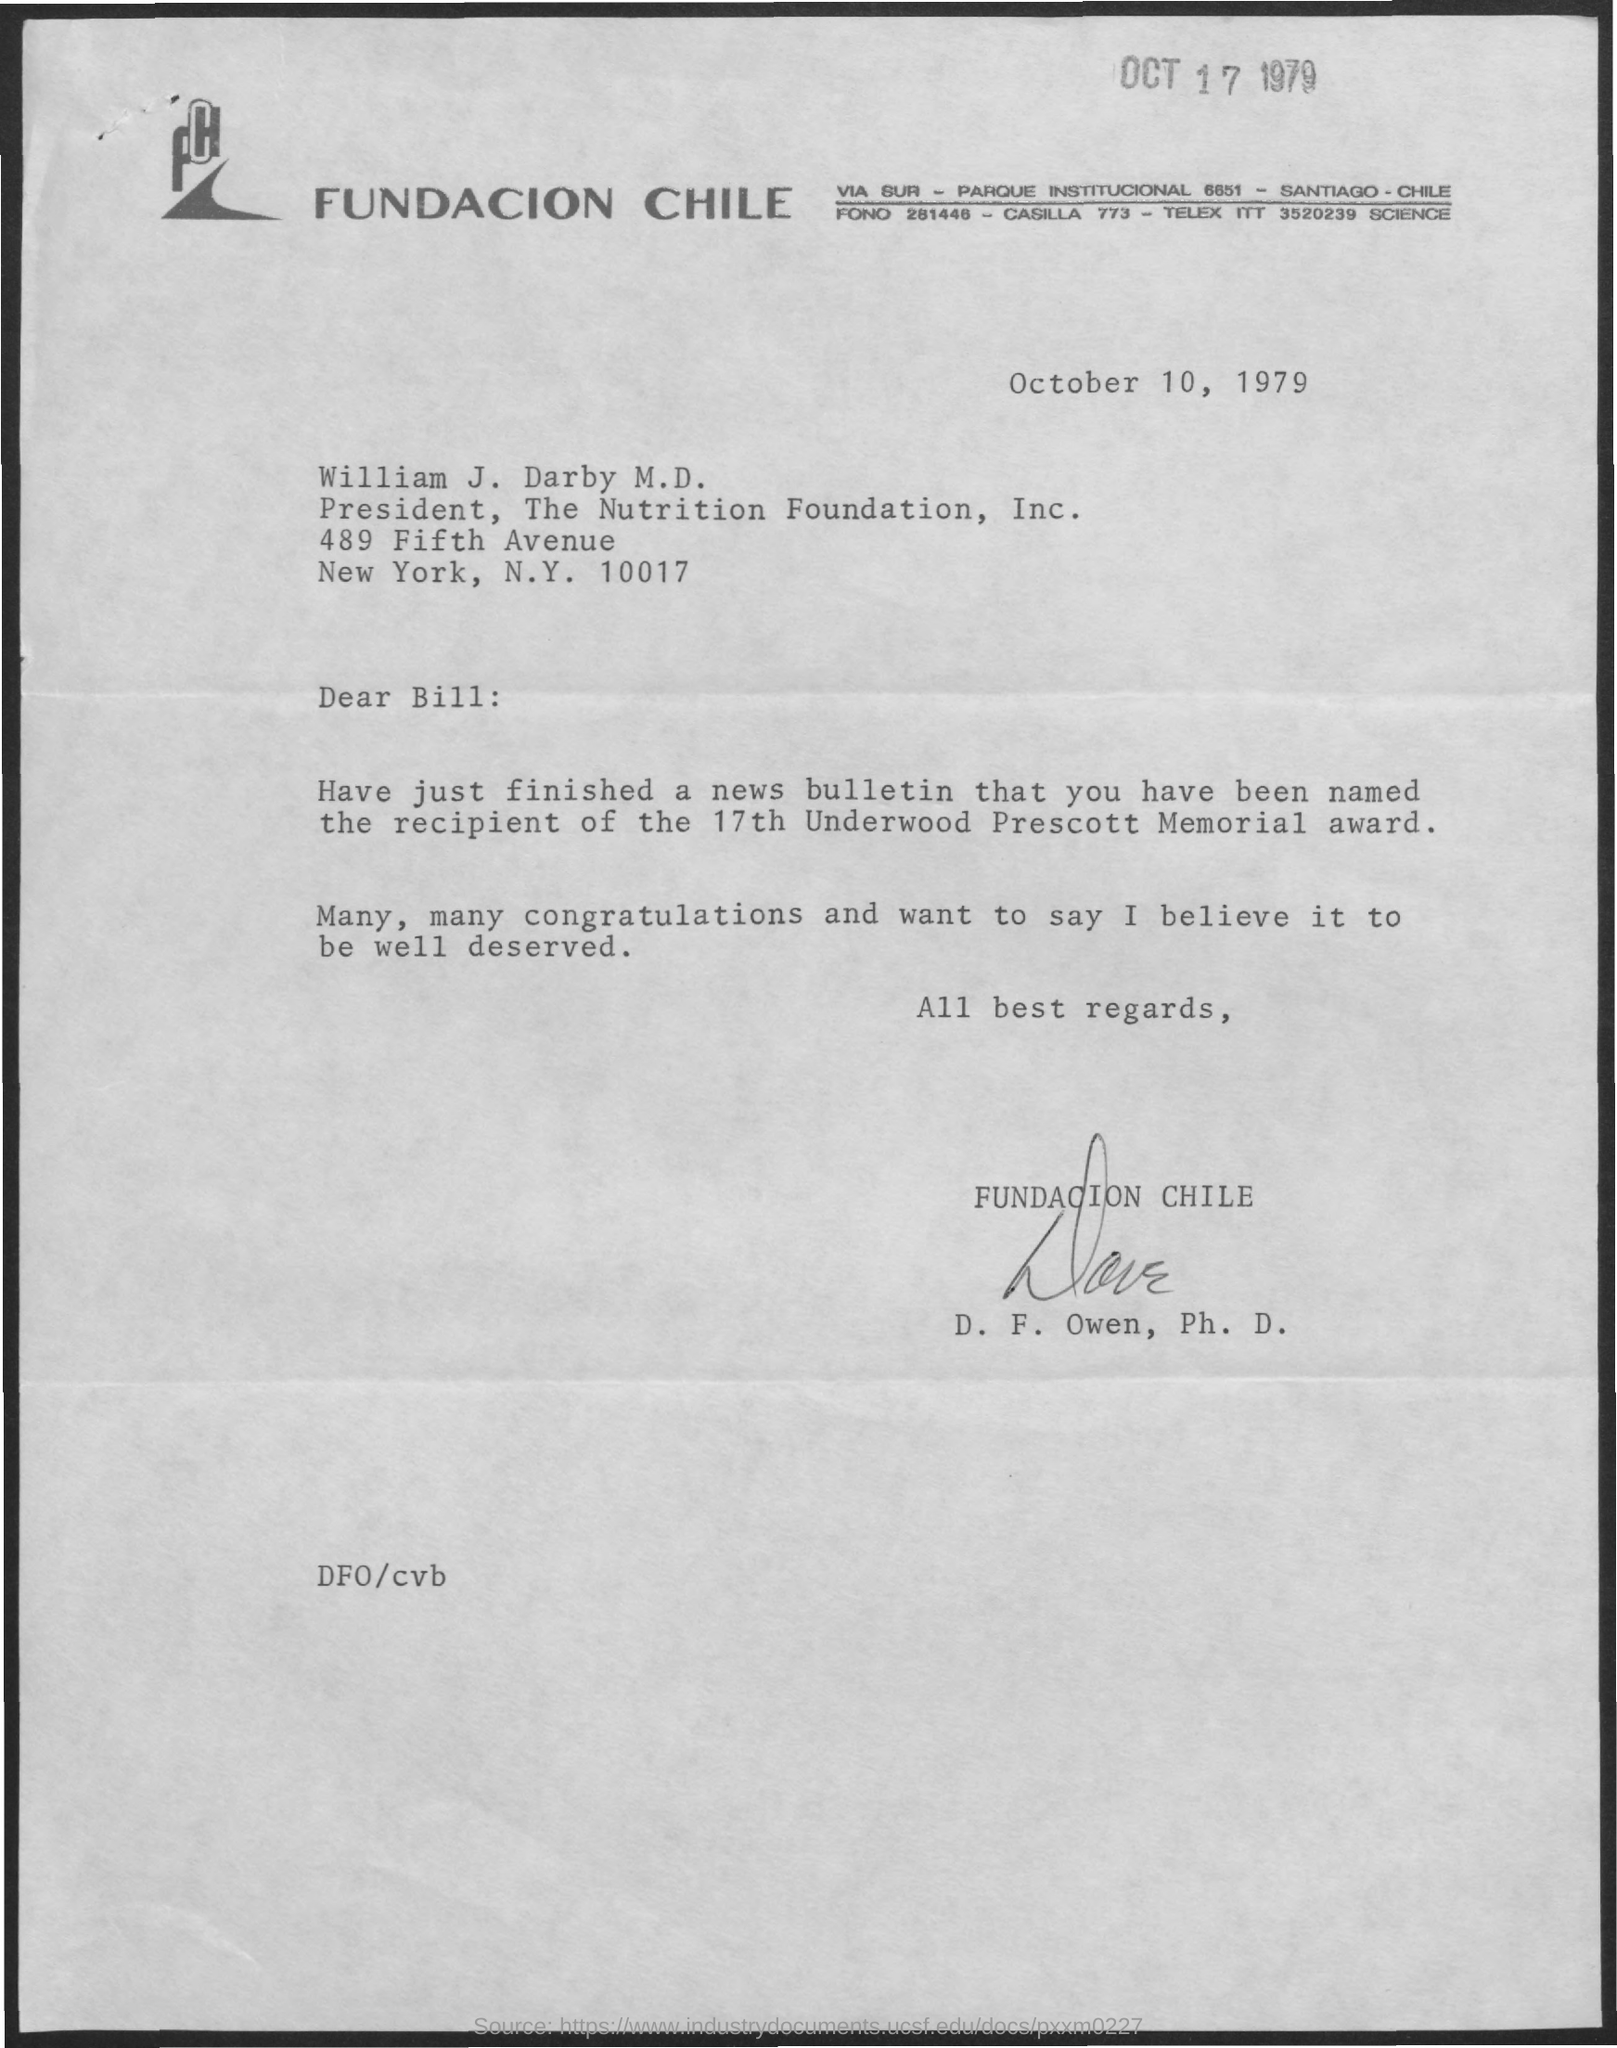What is the date mentioned at the top of the page ?
Your response must be concise. Oct 17 1979. What is the designation of william j darby mentioned ?
Offer a very short reply. President. What is the date mentioned in the given page ?
Keep it short and to the point. October 10, 1979. Who's sign was there at the bottom of the letter ?
Provide a short and direct response. D . F. Owen. 